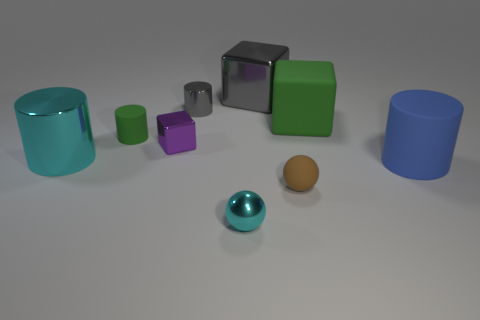Does the tiny rubber cylinder have the same color as the large matte block?
Ensure brevity in your answer.  Yes. How big is the blue rubber cylinder?
Keep it short and to the point. Large. What number of other things are the same material as the large blue thing?
Ensure brevity in your answer.  3. Does the big object in front of the big cyan thing have the same material as the small green cylinder?
Make the answer very short. Yes. Are there more things in front of the cyan cylinder than tiny purple objects behind the purple thing?
Provide a succinct answer. Yes. What number of objects are either tiny matte things that are left of the brown sphere or rubber things?
Provide a succinct answer. 4. There is a small purple object that is made of the same material as the big cyan object; what is its shape?
Provide a succinct answer. Cube. What color is the thing that is on the left side of the tiny brown object and in front of the large blue thing?
Your answer should be very brief. Cyan. How many cylinders are small cyan shiny things or large green objects?
Ensure brevity in your answer.  0. What number of metal spheres are the same size as the blue object?
Make the answer very short. 0. 